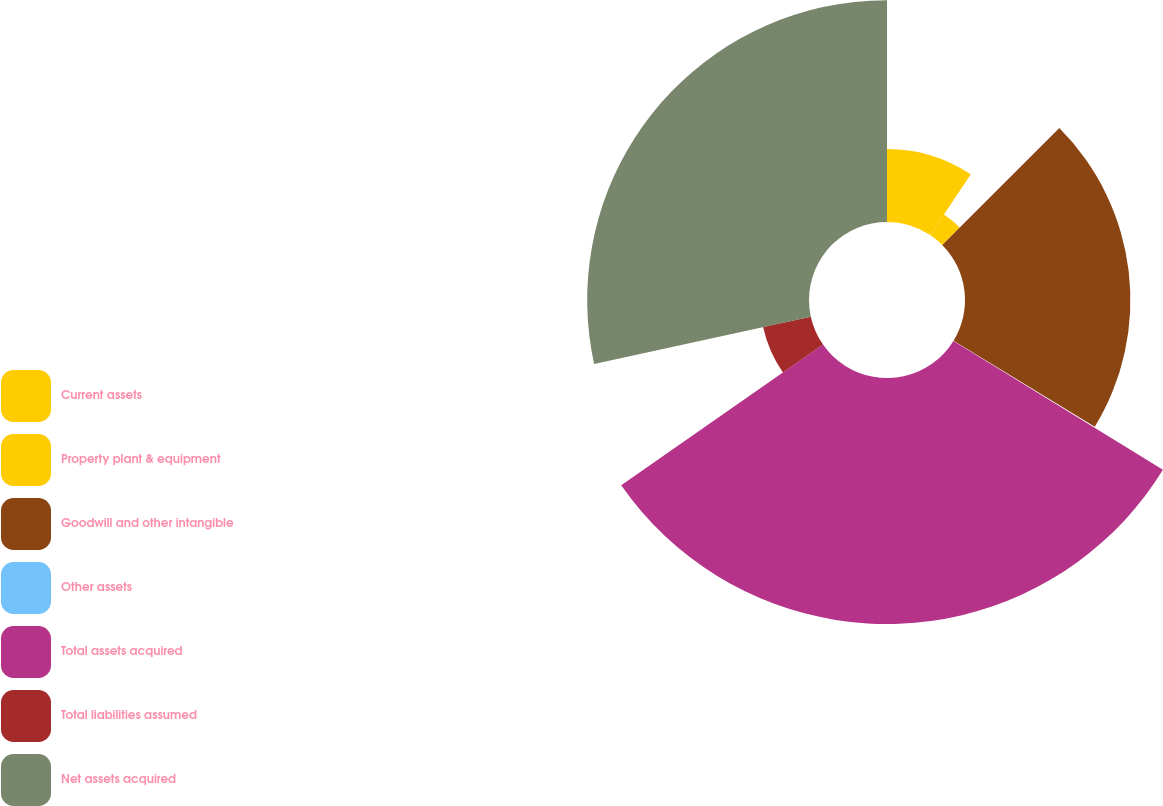Convert chart to OTSL. <chart><loc_0><loc_0><loc_500><loc_500><pie_chart><fcel>Current assets<fcel>Property plant & equipment<fcel>Goodwill and other intangible<fcel>Other assets<fcel>Total assets acquired<fcel>Total liabilities assumed<fcel>Net assets acquired<nl><fcel>9.36%<fcel>3.16%<fcel>21.2%<fcel>0.06%<fcel>31.53%<fcel>6.26%<fcel>28.43%<nl></chart> 